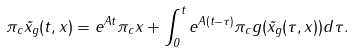Convert formula to latex. <formula><loc_0><loc_0><loc_500><loc_500>\pi _ { c } \tilde { x } _ { g } ( t , x ) = e ^ { A t } \pi _ { c } x + \int _ { 0 } ^ { t } e ^ { A ( t - \tau ) } \pi _ { c } g ( \tilde { x } _ { g } ( \tau , x ) ) d \tau .</formula> 